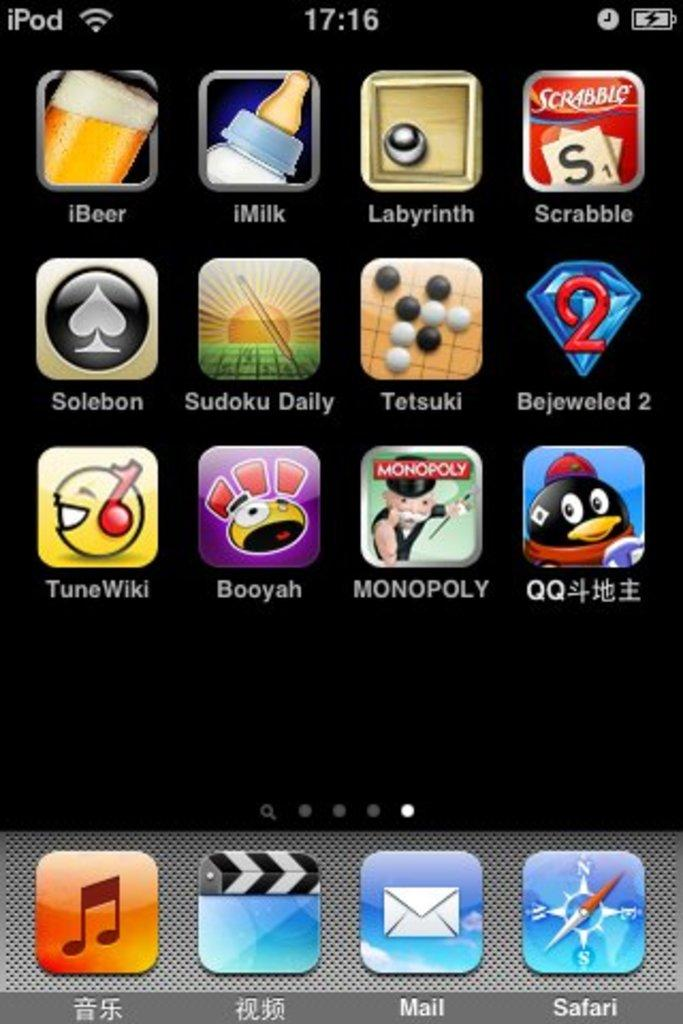<image>
Create a compact narrative representing the image presented. a screenshot of an ipod screen that has an app called 'booyah' on the screen 